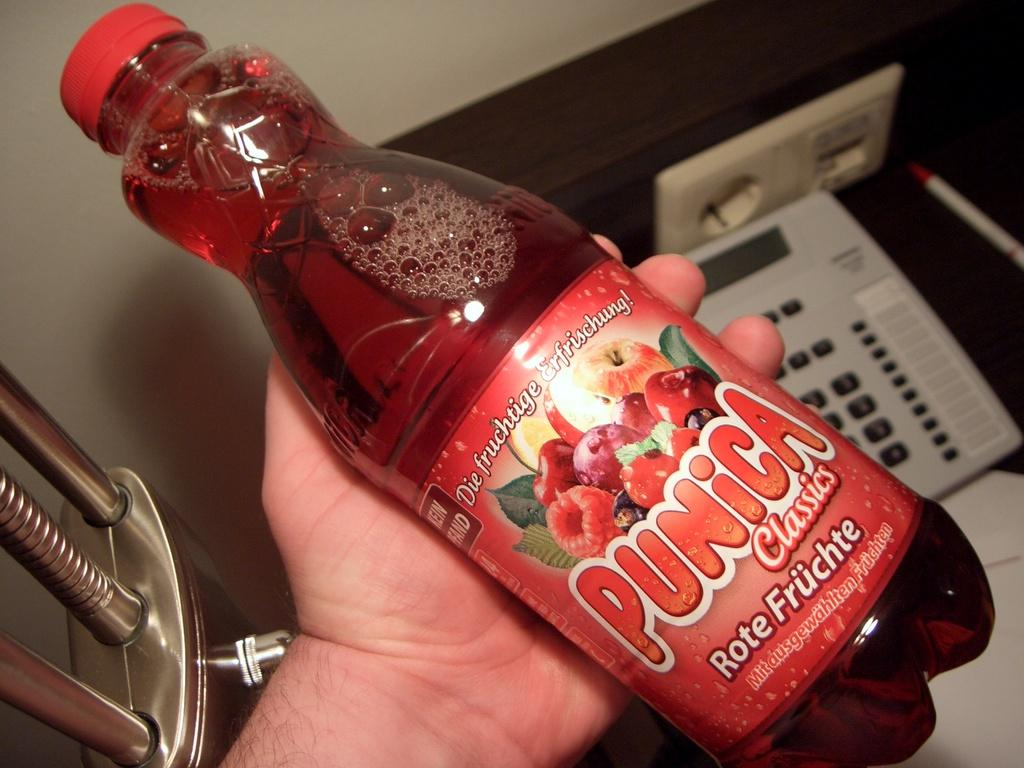What is being held by the hand in the image? There is a hand holding a bottle in the image. What can be observed on the bottle? The bottle has a label. What information is provided on the label? The label contains text. What object is located on the right side of the image? There is a telephone on the right side of the image. How many chin spots can be seen on the bottle in the image? There are no chin spots present on the bottle in the image. What type of fly is sitting on the label of the bottle in the image? There is no fly present on the label of the bottle in the image. 